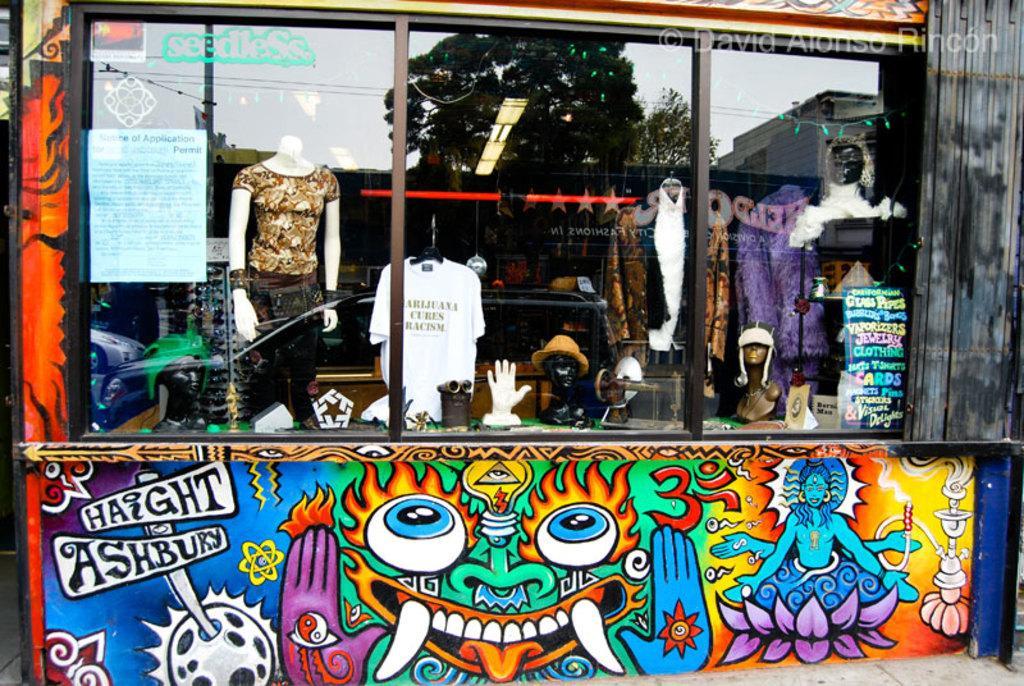Can you describe this image briefly? I think in this picture, there is a store. In the center, there is a wall with glass. On the wall, there are some paintings with different colors. Through the glass, we can see the clothes, mannequins, boards etc. On the glass, there is a reflection of tree and a building. 